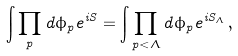Convert formula to latex. <formula><loc_0><loc_0><loc_500><loc_500>\int \prod _ { p } d \phi _ { p } e ^ { i S } = \int \prod _ { p < \Lambda } d \phi _ { p } e ^ { i S _ { \Lambda } } \, ,</formula> 